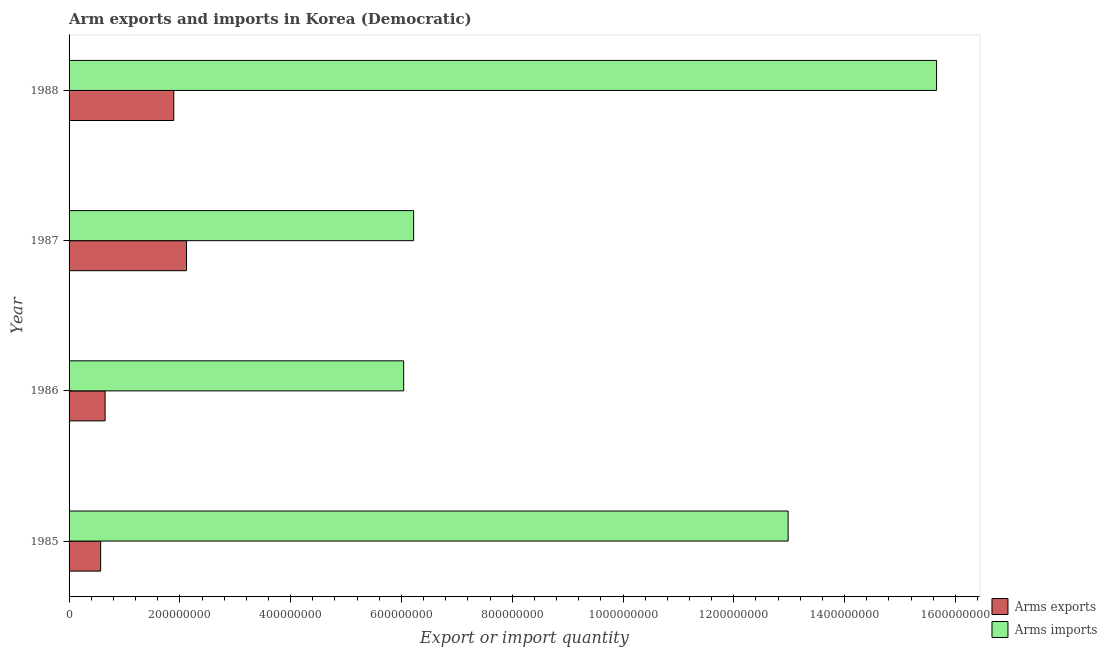How many different coloured bars are there?
Your response must be concise. 2. How many groups of bars are there?
Make the answer very short. 4. How many bars are there on the 1st tick from the top?
Make the answer very short. 2. In how many cases, is the number of bars for a given year not equal to the number of legend labels?
Make the answer very short. 0. What is the arms imports in 1987?
Provide a short and direct response. 6.22e+08. Across all years, what is the maximum arms imports?
Make the answer very short. 1.57e+09. Across all years, what is the minimum arms imports?
Your answer should be very brief. 6.04e+08. In which year was the arms imports minimum?
Ensure brevity in your answer.  1986. What is the total arms imports in the graph?
Make the answer very short. 4.09e+09. What is the difference between the arms exports in 1987 and that in 1988?
Offer a very short reply. 2.30e+07. What is the difference between the arms imports in 1987 and the arms exports in 1986?
Your response must be concise. 5.57e+08. What is the average arms imports per year?
Provide a succinct answer. 1.02e+09. In the year 1985, what is the difference between the arms imports and arms exports?
Keep it short and to the point. 1.24e+09. In how many years, is the arms exports greater than 840000000 ?
Keep it short and to the point. 0. What is the ratio of the arms exports in 1985 to that in 1986?
Provide a short and direct response. 0.88. Is the arms exports in 1986 less than that in 1988?
Give a very brief answer. Yes. What is the difference between the highest and the second highest arms imports?
Your answer should be very brief. 2.68e+08. What is the difference between the highest and the lowest arms exports?
Give a very brief answer. 1.55e+08. In how many years, is the arms exports greater than the average arms exports taken over all years?
Provide a short and direct response. 2. Is the sum of the arms imports in 1987 and 1988 greater than the maximum arms exports across all years?
Keep it short and to the point. Yes. What does the 1st bar from the top in 1988 represents?
Provide a succinct answer. Arms imports. What does the 1st bar from the bottom in 1987 represents?
Your answer should be very brief. Arms exports. Are all the bars in the graph horizontal?
Keep it short and to the point. Yes. What is the difference between two consecutive major ticks on the X-axis?
Provide a succinct answer. 2.00e+08. Does the graph contain any zero values?
Your answer should be very brief. No. Where does the legend appear in the graph?
Offer a terse response. Bottom right. How many legend labels are there?
Your answer should be very brief. 2. What is the title of the graph?
Your response must be concise. Arm exports and imports in Korea (Democratic). Does "Primary" appear as one of the legend labels in the graph?
Offer a terse response. No. What is the label or title of the X-axis?
Your answer should be compact. Export or import quantity. What is the label or title of the Y-axis?
Your answer should be very brief. Year. What is the Export or import quantity of Arms exports in 1985?
Ensure brevity in your answer.  5.70e+07. What is the Export or import quantity of Arms imports in 1985?
Give a very brief answer. 1.30e+09. What is the Export or import quantity in Arms exports in 1986?
Your answer should be very brief. 6.50e+07. What is the Export or import quantity of Arms imports in 1986?
Provide a succinct answer. 6.04e+08. What is the Export or import quantity of Arms exports in 1987?
Ensure brevity in your answer.  2.12e+08. What is the Export or import quantity in Arms imports in 1987?
Provide a short and direct response. 6.22e+08. What is the Export or import quantity in Arms exports in 1988?
Provide a short and direct response. 1.89e+08. What is the Export or import quantity of Arms imports in 1988?
Keep it short and to the point. 1.57e+09. Across all years, what is the maximum Export or import quantity in Arms exports?
Your answer should be very brief. 2.12e+08. Across all years, what is the maximum Export or import quantity of Arms imports?
Your response must be concise. 1.57e+09. Across all years, what is the minimum Export or import quantity in Arms exports?
Ensure brevity in your answer.  5.70e+07. Across all years, what is the minimum Export or import quantity in Arms imports?
Offer a terse response. 6.04e+08. What is the total Export or import quantity of Arms exports in the graph?
Give a very brief answer. 5.23e+08. What is the total Export or import quantity of Arms imports in the graph?
Offer a very short reply. 4.09e+09. What is the difference between the Export or import quantity of Arms exports in 1985 and that in 1986?
Offer a terse response. -8.00e+06. What is the difference between the Export or import quantity of Arms imports in 1985 and that in 1986?
Make the answer very short. 6.94e+08. What is the difference between the Export or import quantity of Arms exports in 1985 and that in 1987?
Your answer should be compact. -1.55e+08. What is the difference between the Export or import quantity of Arms imports in 1985 and that in 1987?
Your answer should be compact. 6.76e+08. What is the difference between the Export or import quantity of Arms exports in 1985 and that in 1988?
Give a very brief answer. -1.32e+08. What is the difference between the Export or import quantity in Arms imports in 1985 and that in 1988?
Keep it short and to the point. -2.68e+08. What is the difference between the Export or import quantity of Arms exports in 1986 and that in 1987?
Provide a short and direct response. -1.47e+08. What is the difference between the Export or import quantity in Arms imports in 1986 and that in 1987?
Make the answer very short. -1.80e+07. What is the difference between the Export or import quantity in Arms exports in 1986 and that in 1988?
Keep it short and to the point. -1.24e+08. What is the difference between the Export or import quantity of Arms imports in 1986 and that in 1988?
Your answer should be compact. -9.62e+08. What is the difference between the Export or import quantity of Arms exports in 1987 and that in 1988?
Offer a very short reply. 2.30e+07. What is the difference between the Export or import quantity of Arms imports in 1987 and that in 1988?
Keep it short and to the point. -9.44e+08. What is the difference between the Export or import quantity in Arms exports in 1985 and the Export or import quantity in Arms imports in 1986?
Ensure brevity in your answer.  -5.47e+08. What is the difference between the Export or import quantity in Arms exports in 1985 and the Export or import quantity in Arms imports in 1987?
Your answer should be very brief. -5.65e+08. What is the difference between the Export or import quantity in Arms exports in 1985 and the Export or import quantity in Arms imports in 1988?
Make the answer very short. -1.51e+09. What is the difference between the Export or import quantity of Arms exports in 1986 and the Export or import quantity of Arms imports in 1987?
Your answer should be compact. -5.57e+08. What is the difference between the Export or import quantity of Arms exports in 1986 and the Export or import quantity of Arms imports in 1988?
Offer a very short reply. -1.50e+09. What is the difference between the Export or import quantity of Arms exports in 1987 and the Export or import quantity of Arms imports in 1988?
Give a very brief answer. -1.35e+09. What is the average Export or import quantity of Arms exports per year?
Make the answer very short. 1.31e+08. What is the average Export or import quantity in Arms imports per year?
Your answer should be very brief. 1.02e+09. In the year 1985, what is the difference between the Export or import quantity of Arms exports and Export or import quantity of Arms imports?
Keep it short and to the point. -1.24e+09. In the year 1986, what is the difference between the Export or import quantity of Arms exports and Export or import quantity of Arms imports?
Provide a succinct answer. -5.39e+08. In the year 1987, what is the difference between the Export or import quantity in Arms exports and Export or import quantity in Arms imports?
Give a very brief answer. -4.10e+08. In the year 1988, what is the difference between the Export or import quantity of Arms exports and Export or import quantity of Arms imports?
Ensure brevity in your answer.  -1.38e+09. What is the ratio of the Export or import quantity in Arms exports in 1985 to that in 1986?
Give a very brief answer. 0.88. What is the ratio of the Export or import quantity in Arms imports in 1985 to that in 1986?
Offer a terse response. 2.15. What is the ratio of the Export or import quantity of Arms exports in 1985 to that in 1987?
Your answer should be compact. 0.27. What is the ratio of the Export or import quantity of Arms imports in 1985 to that in 1987?
Your response must be concise. 2.09. What is the ratio of the Export or import quantity of Arms exports in 1985 to that in 1988?
Give a very brief answer. 0.3. What is the ratio of the Export or import quantity of Arms imports in 1985 to that in 1988?
Ensure brevity in your answer.  0.83. What is the ratio of the Export or import quantity in Arms exports in 1986 to that in 1987?
Offer a terse response. 0.31. What is the ratio of the Export or import quantity of Arms imports in 1986 to that in 1987?
Make the answer very short. 0.97. What is the ratio of the Export or import quantity in Arms exports in 1986 to that in 1988?
Your answer should be compact. 0.34. What is the ratio of the Export or import quantity in Arms imports in 1986 to that in 1988?
Your response must be concise. 0.39. What is the ratio of the Export or import quantity in Arms exports in 1987 to that in 1988?
Offer a very short reply. 1.12. What is the ratio of the Export or import quantity in Arms imports in 1987 to that in 1988?
Ensure brevity in your answer.  0.4. What is the difference between the highest and the second highest Export or import quantity of Arms exports?
Make the answer very short. 2.30e+07. What is the difference between the highest and the second highest Export or import quantity of Arms imports?
Offer a very short reply. 2.68e+08. What is the difference between the highest and the lowest Export or import quantity in Arms exports?
Ensure brevity in your answer.  1.55e+08. What is the difference between the highest and the lowest Export or import quantity in Arms imports?
Offer a terse response. 9.62e+08. 